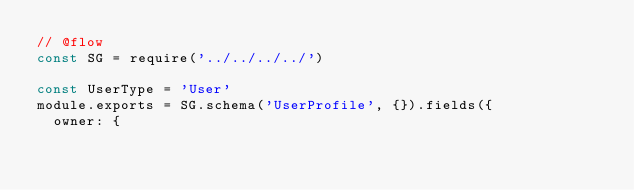<code> <loc_0><loc_0><loc_500><loc_500><_JavaScript_>// @flow
const SG = require('../../../../')

const UserType = 'User'
module.exports = SG.schema('UserProfile', {}).fields({
  owner: {</code> 